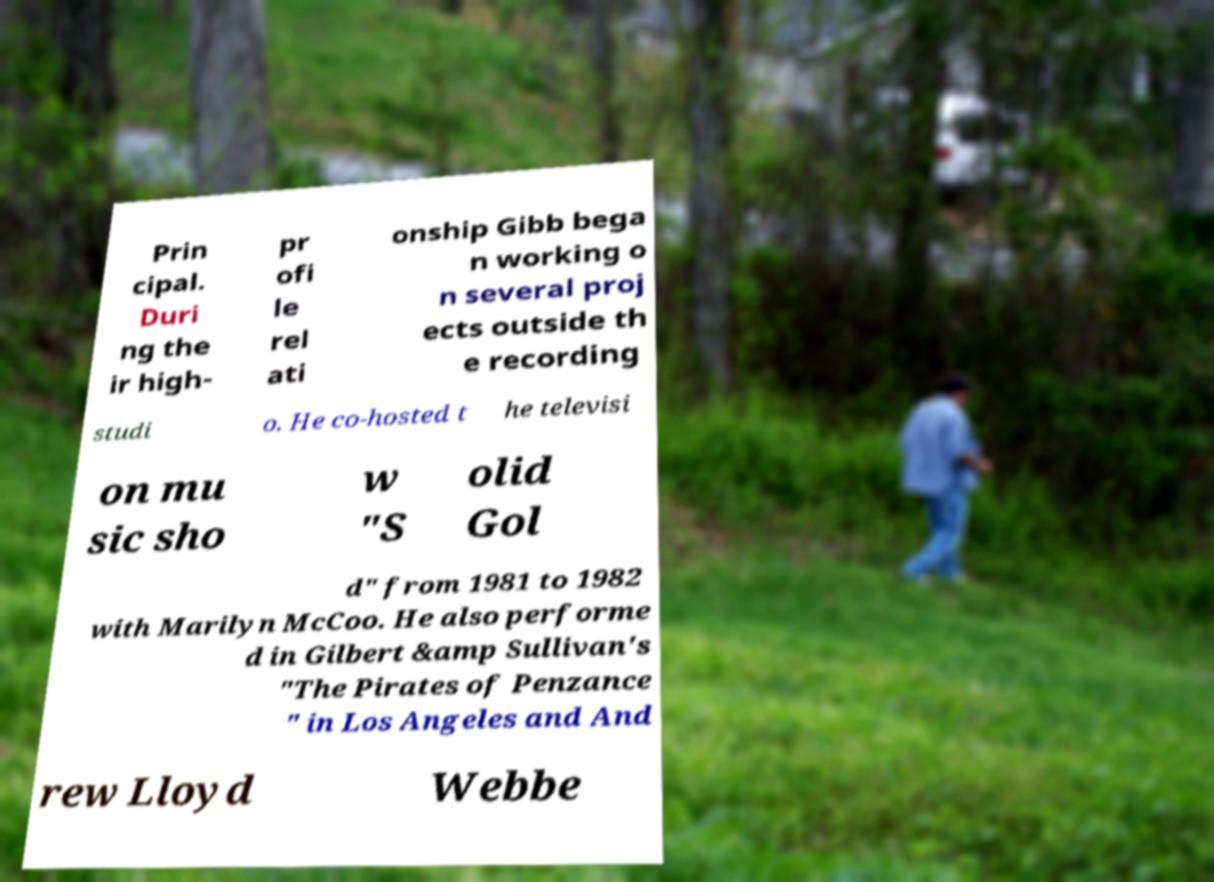For documentation purposes, I need the text within this image transcribed. Could you provide that? Prin cipal. Duri ng the ir high- pr ofi le rel ati onship Gibb bega n working o n several proj ects outside th e recording studi o. He co-hosted t he televisi on mu sic sho w "S olid Gol d" from 1981 to 1982 with Marilyn McCoo. He also performe d in Gilbert &amp Sullivan's "The Pirates of Penzance " in Los Angeles and And rew Lloyd Webbe 